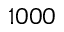Convert formula to latex. <formula><loc_0><loc_0><loc_500><loc_500>1 0 0 0</formula> 